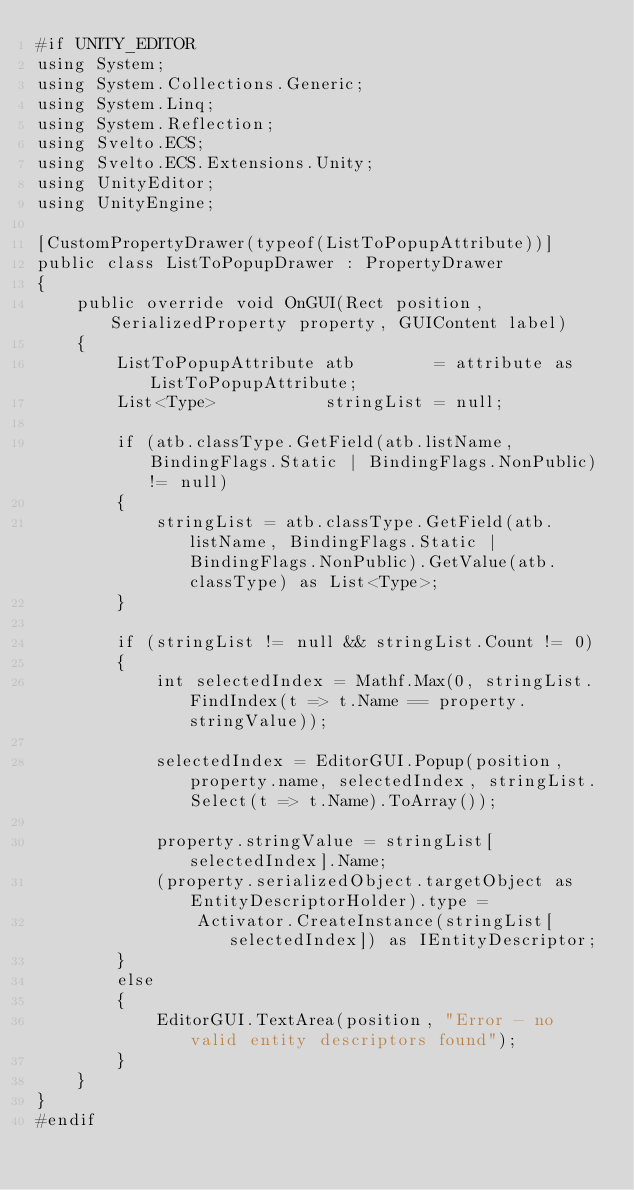Convert code to text. <code><loc_0><loc_0><loc_500><loc_500><_C#_>#if UNITY_EDITOR
using System;
using System.Collections.Generic;
using System.Linq;
using System.Reflection;
using Svelto.ECS;
using Svelto.ECS.Extensions.Unity;
using UnityEditor;
using UnityEngine;

[CustomPropertyDrawer(typeof(ListToPopupAttribute))]
public class ListToPopupDrawer : PropertyDrawer
{
    public override void OnGUI(Rect position, SerializedProperty property, GUIContent label)
    {
        ListToPopupAttribute atb        = attribute as ListToPopupAttribute;
        List<Type>           stringList = null;

        if (atb.classType.GetField(atb.listName, BindingFlags.Static | BindingFlags.NonPublic) != null)
        {
            stringList = atb.classType.GetField(atb.listName, BindingFlags.Static | BindingFlags.NonPublic).GetValue(atb.classType) as List<Type>;
        }

        if (stringList != null && stringList.Count != 0)
        {
            int selectedIndex = Mathf.Max(0, stringList.FindIndex(t => t.Name == property.stringValue)); 
            
            selectedIndex = EditorGUI.Popup(position, property.name, selectedIndex, stringList.Select(t => t.Name).ToArray());

            property.stringValue = stringList[selectedIndex].Name;
            (property.serializedObject.targetObject as EntityDescriptorHolder).type =
                Activator.CreateInstance(stringList[selectedIndex]) as IEntityDescriptor;
        }
        else
        {
            EditorGUI.TextArea(position, "Error - no valid entity descriptors found");
        }
    }
}
#endif</code> 